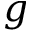<formula> <loc_0><loc_0><loc_500><loc_500>g</formula> 